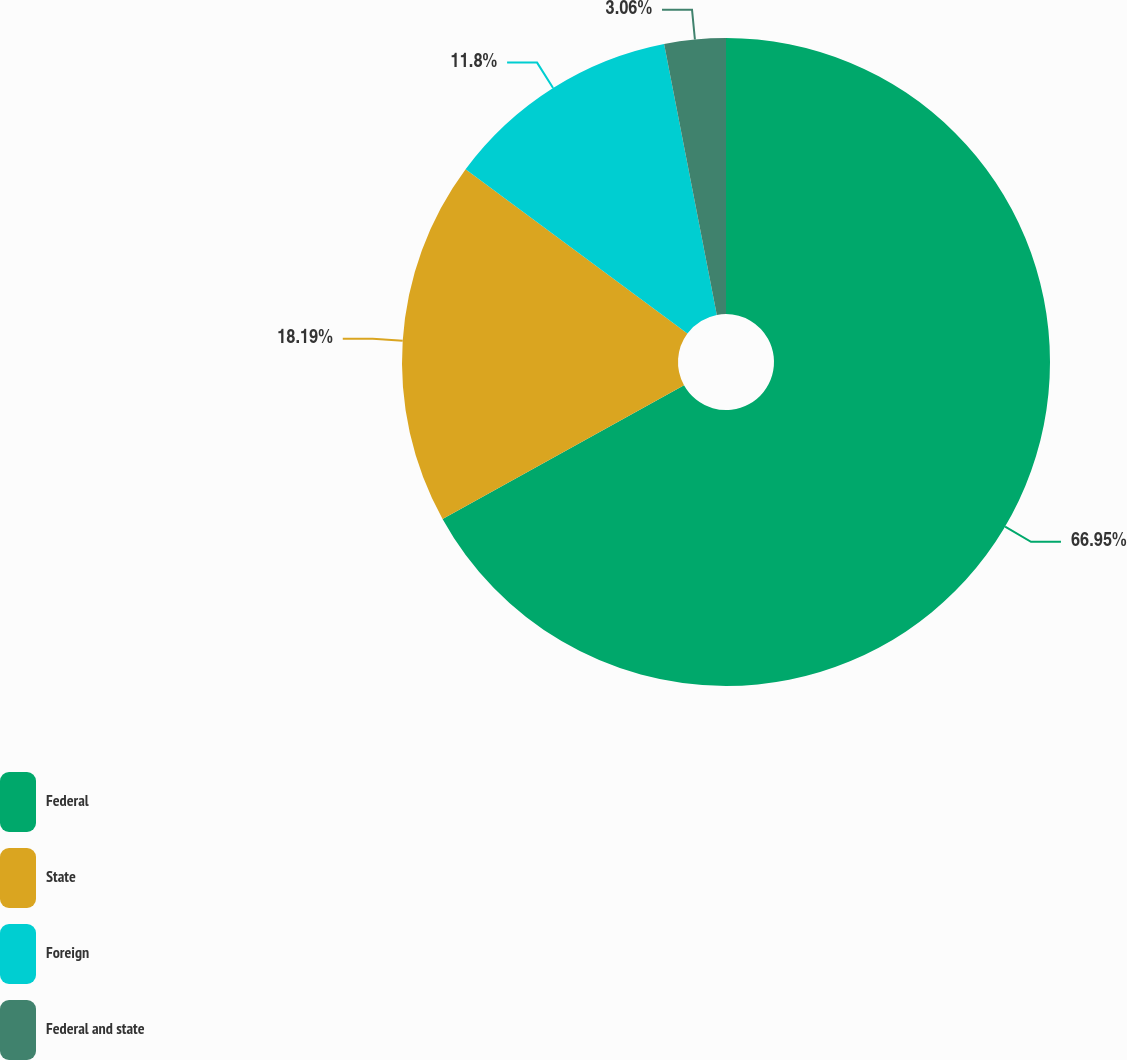<chart> <loc_0><loc_0><loc_500><loc_500><pie_chart><fcel>Federal<fcel>State<fcel>Foreign<fcel>Federal and state<nl><fcel>66.96%<fcel>18.19%<fcel>11.8%<fcel>3.06%<nl></chart> 